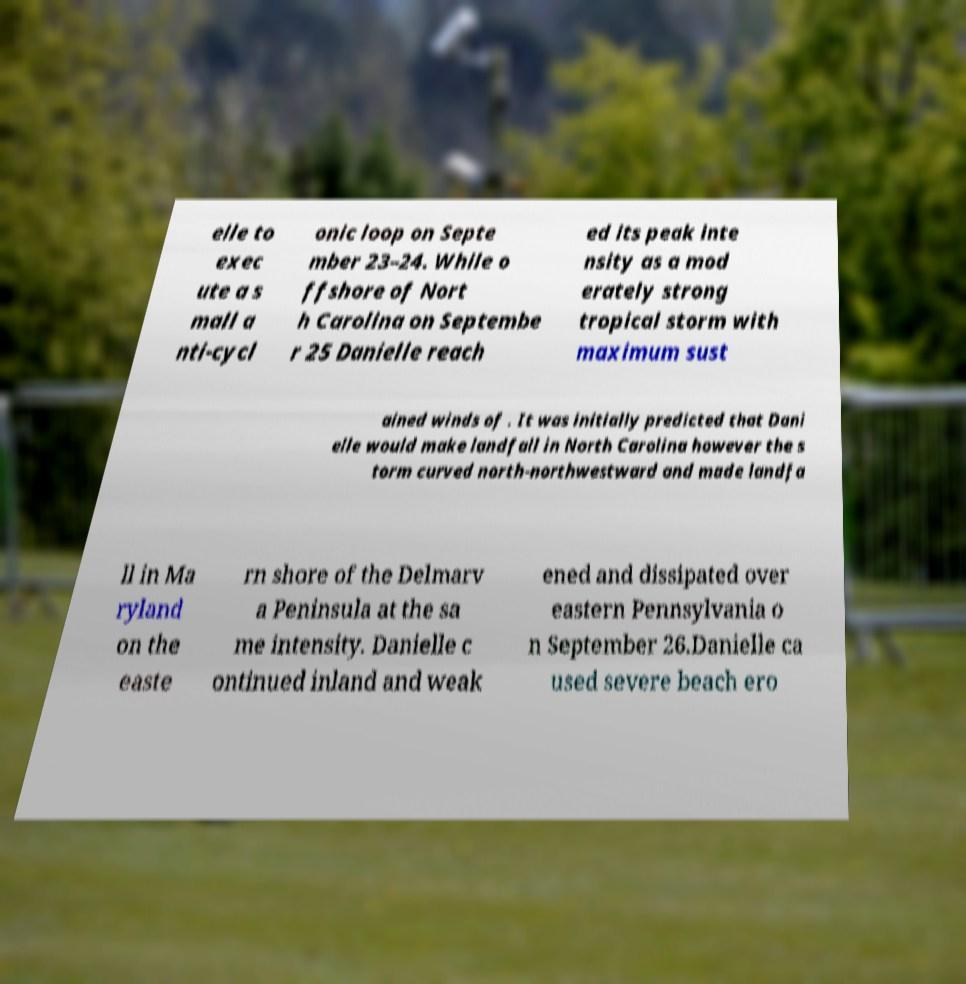Can you read and provide the text displayed in the image?This photo seems to have some interesting text. Can you extract and type it out for me? elle to exec ute a s mall a nti-cycl onic loop on Septe mber 23–24. While o ffshore of Nort h Carolina on Septembe r 25 Danielle reach ed its peak inte nsity as a mod erately strong tropical storm with maximum sust ained winds of . It was initially predicted that Dani elle would make landfall in North Carolina however the s torm curved north-northwestward and made landfa ll in Ma ryland on the easte rn shore of the Delmarv a Peninsula at the sa me intensity. Danielle c ontinued inland and weak ened and dissipated over eastern Pennsylvania o n September 26.Danielle ca used severe beach ero 